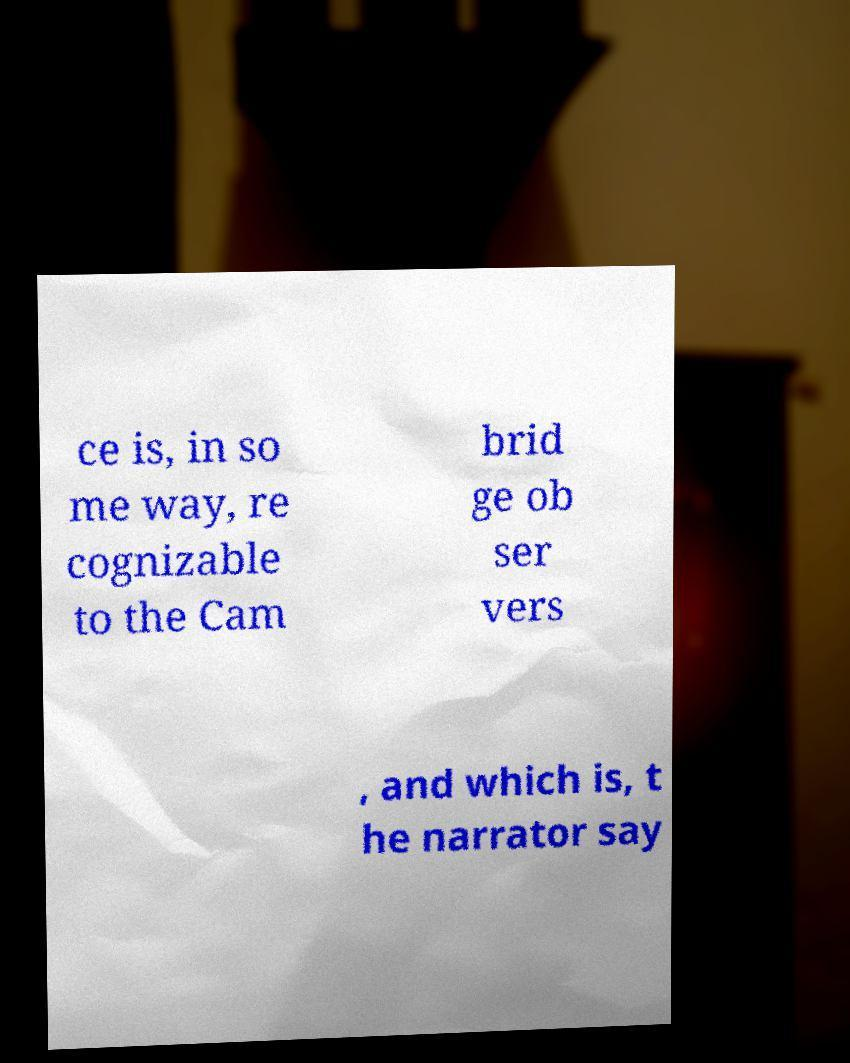Can you accurately transcribe the text from the provided image for me? ce is, in so me way, re cognizable to the Cam brid ge ob ser vers , and which is, t he narrator say 